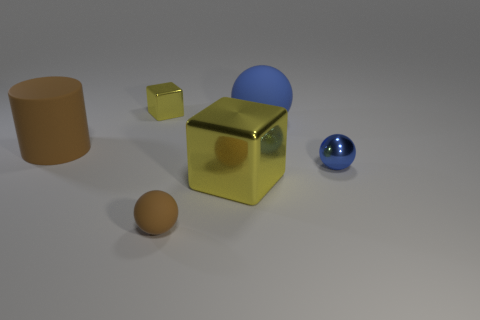What number of blue things have the same material as the big brown object?
Provide a succinct answer. 1. There is a yellow block that is in front of the big blue thing; what is it made of?
Give a very brief answer. Metal. What is the shape of the big rubber object behind the large thing that is left of the matte sphere that is left of the big blue rubber sphere?
Keep it short and to the point. Sphere. Does the cube that is behind the big blue thing have the same color as the rubber thing that is in front of the tiny blue shiny sphere?
Your answer should be compact. No. Are there fewer big matte things that are in front of the big brown rubber thing than small blue spheres on the right side of the small blue metal ball?
Your answer should be compact. No. Is there any other thing that has the same shape as the tiny blue object?
Provide a succinct answer. Yes. What color is the other big thing that is the same shape as the blue shiny object?
Your response must be concise. Blue. There is a big brown object; is its shape the same as the tiny matte thing in front of the large brown object?
Your answer should be compact. No. What number of objects are either tiny things to the left of the big blue rubber thing or yellow things that are in front of the big matte cylinder?
Make the answer very short. 3. What material is the large yellow block?
Your answer should be very brief. Metal. 